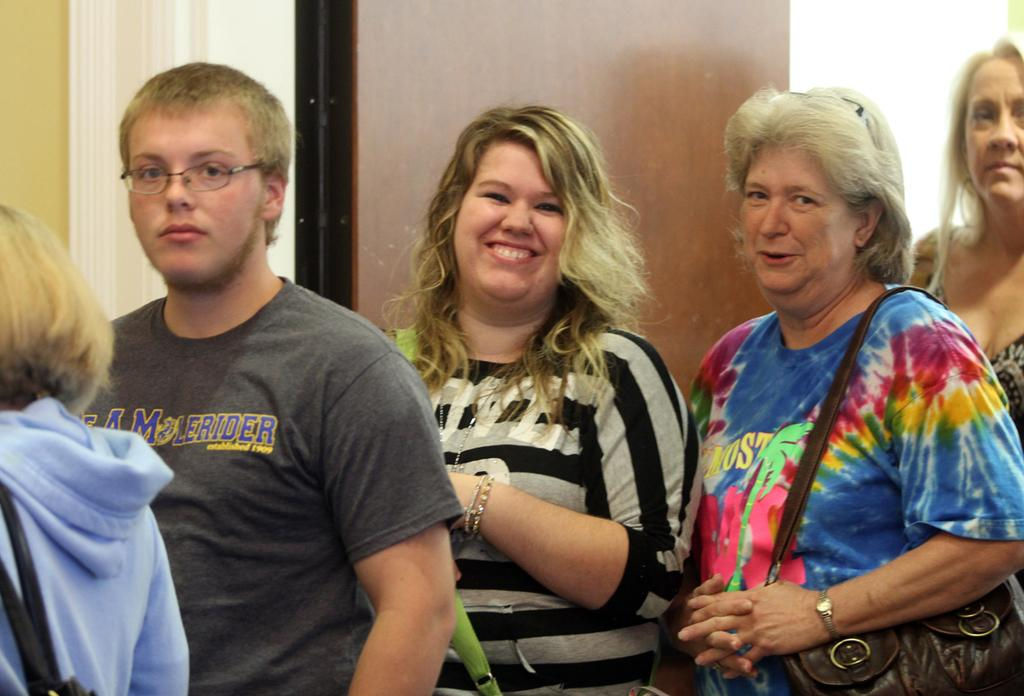Who is present in the image? There are people in the image. What is the facial expression of the people in the image? The people in the image are smiling. What type of window treatment is visible in the image? There is a curtain in the image. What material is the wall made of in the image? There is a wooden wall in the image. Where is the goat located in the image? There is no goat present in the image. What type of mine is visible in the image? There is no mine present in the image. 